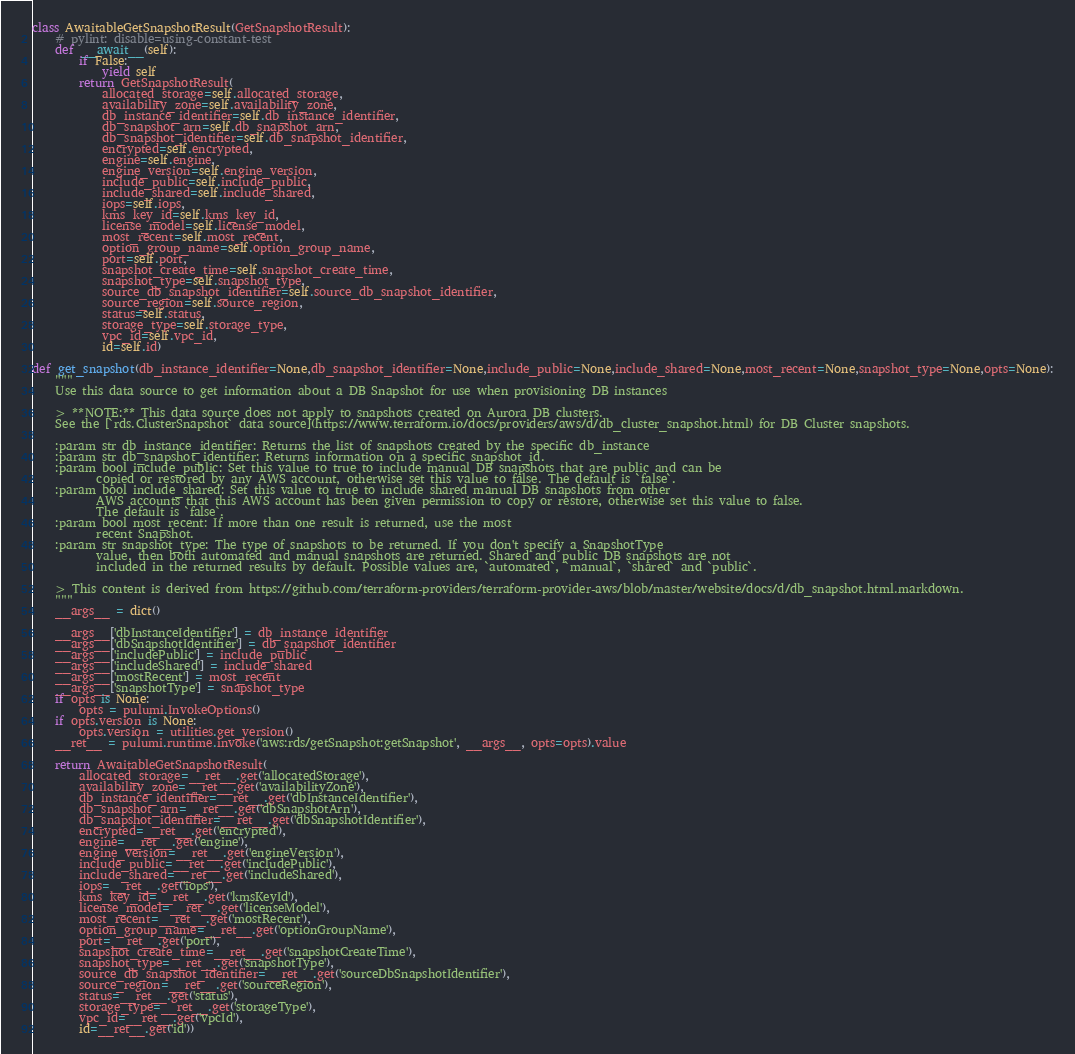Convert code to text. <code><loc_0><loc_0><loc_500><loc_500><_Python_>class AwaitableGetSnapshotResult(GetSnapshotResult):
    # pylint: disable=using-constant-test
    def __await__(self):
        if False:
            yield self
        return GetSnapshotResult(
            allocated_storage=self.allocated_storage,
            availability_zone=self.availability_zone,
            db_instance_identifier=self.db_instance_identifier,
            db_snapshot_arn=self.db_snapshot_arn,
            db_snapshot_identifier=self.db_snapshot_identifier,
            encrypted=self.encrypted,
            engine=self.engine,
            engine_version=self.engine_version,
            include_public=self.include_public,
            include_shared=self.include_shared,
            iops=self.iops,
            kms_key_id=self.kms_key_id,
            license_model=self.license_model,
            most_recent=self.most_recent,
            option_group_name=self.option_group_name,
            port=self.port,
            snapshot_create_time=self.snapshot_create_time,
            snapshot_type=self.snapshot_type,
            source_db_snapshot_identifier=self.source_db_snapshot_identifier,
            source_region=self.source_region,
            status=self.status,
            storage_type=self.storage_type,
            vpc_id=self.vpc_id,
            id=self.id)

def get_snapshot(db_instance_identifier=None,db_snapshot_identifier=None,include_public=None,include_shared=None,most_recent=None,snapshot_type=None,opts=None):
    """
    Use this data source to get information about a DB Snapshot for use when provisioning DB instances
    
    > **NOTE:** This data source does not apply to snapshots created on Aurora DB clusters.
    See the [`rds.ClusterSnapshot` data source](https://www.terraform.io/docs/providers/aws/d/db_cluster_snapshot.html) for DB Cluster snapshots.
    
    :param str db_instance_identifier: Returns the list of snapshots created by the specific db_instance
    :param str db_snapshot_identifier: Returns information on a specific snapshot_id.
    :param bool include_public: Set this value to true to include manual DB snapshots that are public and can be
           copied or restored by any AWS account, otherwise set this value to false. The default is `false`.
    :param bool include_shared: Set this value to true to include shared manual DB snapshots from other
           AWS accounts that this AWS account has been given permission to copy or restore, otherwise set this value to false.
           The default is `false`.
    :param bool most_recent: If more than one result is returned, use the most
           recent Snapshot.
    :param str snapshot_type: The type of snapshots to be returned. If you don't specify a SnapshotType
           value, then both automated and manual snapshots are returned. Shared and public DB snapshots are not
           included in the returned results by default. Possible values are, `automated`, `manual`, `shared` and `public`.

    > This content is derived from https://github.com/terraform-providers/terraform-provider-aws/blob/master/website/docs/d/db_snapshot.html.markdown.
    """
    __args__ = dict()

    __args__['dbInstanceIdentifier'] = db_instance_identifier
    __args__['dbSnapshotIdentifier'] = db_snapshot_identifier
    __args__['includePublic'] = include_public
    __args__['includeShared'] = include_shared
    __args__['mostRecent'] = most_recent
    __args__['snapshotType'] = snapshot_type
    if opts is None:
        opts = pulumi.InvokeOptions()
    if opts.version is None:
        opts.version = utilities.get_version()
    __ret__ = pulumi.runtime.invoke('aws:rds/getSnapshot:getSnapshot', __args__, opts=opts).value

    return AwaitableGetSnapshotResult(
        allocated_storage=__ret__.get('allocatedStorage'),
        availability_zone=__ret__.get('availabilityZone'),
        db_instance_identifier=__ret__.get('dbInstanceIdentifier'),
        db_snapshot_arn=__ret__.get('dbSnapshotArn'),
        db_snapshot_identifier=__ret__.get('dbSnapshotIdentifier'),
        encrypted=__ret__.get('encrypted'),
        engine=__ret__.get('engine'),
        engine_version=__ret__.get('engineVersion'),
        include_public=__ret__.get('includePublic'),
        include_shared=__ret__.get('includeShared'),
        iops=__ret__.get('iops'),
        kms_key_id=__ret__.get('kmsKeyId'),
        license_model=__ret__.get('licenseModel'),
        most_recent=__ret__.get('mostRecent'),
        option_group_name=__ret__.get('optionGroupName'),
        port=__ret__.get('port'),
        snapshot_create_time=__ret__.get('snapshotCreateTime'),
        snapshot_type=__ret__.get('snapshotType'),
        source_db_snapshot_identifier=__ret__.get('sourceDbSnapshotIdentifier'),
        source_region=__ret__.get('sourceRegion'),
        status=__ret__.get('status'),
        storage_type=__ret__.get('storageType'),
        vpc_id=__ret__.get('vpcId'),
        id=__ret__.get('id'))
</code> 